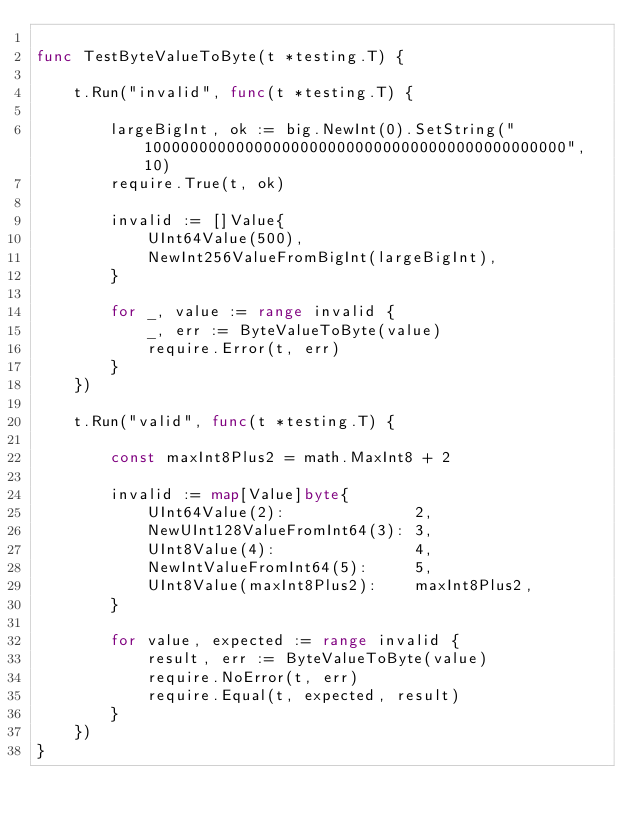<code> <loc_0><loc_0><loc_500><loc_500><_Go_>
func TestByteValueToByte(t *testing.T) {

	t.Run("invalid", func(t *testing.T) {

		largeBigInt, ok := big.NewInt(0).SetString("1000000000000000000000000000000000000000000000", 10)
		require.True(t, ok)

		invalid := []Value{
			UInt64Value(500),
			NewInt256ValueFromBigInt(largeBigInt),
		}

		for _, value := range invalid {
			_, err := ByteValueToByte(value)
			require.Error(t, err)
		}
	})

	t.Run("valid", func(t *testing.T) {

		const maxInt8Plus2 = math.MaxInt8 + 2

		invalid := map[Value]byte{
			UInt64Value(2):              2,
			NewUInt128ValueFromInt64(3): 3,
			UInt8Value(4):               4,
			NewIntValueFromInt64(5):     5,
			UInt8Value(maxInt8Plus2):    maxInt8Plus2,
		}

		for value, expected := range invalid {
			result, err := ByteValueToByte(value)
			require.NoError(t, err)
			require.Equal(t, expected, result)
		}
	})
}
</code> 